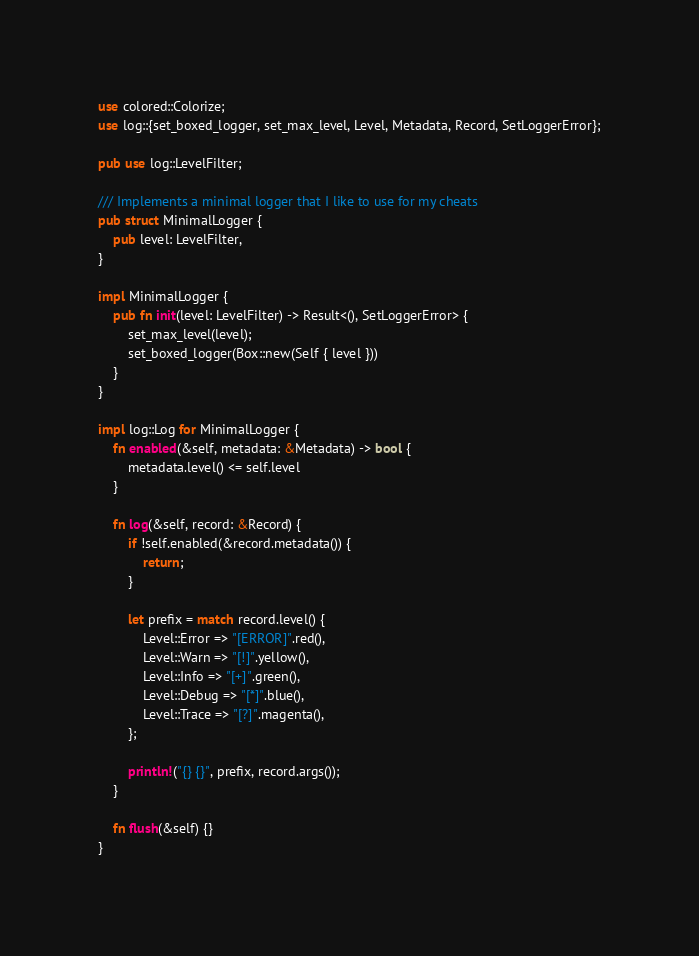Convert code to text. <code><loc_0><loc_0><loc_500><loc_500><_Rust_>use colored::Colorize;
use log::{set_boxed_logger, set_max_level, Level, Metadata, Record, SetLoggerError};

pub use log::LevelFilter;

/// Implements a minimal logger that I like to use for my cheats
pub struct MinimalLogger {
    pub level: LevelFilter,
}

impl MinimalLogger {
    pub fn init(level: LevelFilter) -> Result<(), SetLoggerError> {
        set_max_level(level);
        set_boxed_logger(Box::new(Self { level }))
    }
}

impl log::Log for MinimalLogger {
    fn enabled(&self, metadata: &Metadata) -> bool {
        metadata.level() <= self.level
    }

    fn log(&self, record: &Record) {
        if !self.enabled(&record.metadata()) {
            return;
        }

        let prefix = match record.level() {
            Level::Error => "[ERROR]".red(),
            Level::Warn => "[!]".yellow(),
            Level::Info => "[+]".green(),
            Level::Debug => "[*]".blue(),
            Level::Trace => "[?]".magenta(),
        };

        println!("{} {}", prefix, record.args());
    }

    fn flush(&self) {}
}
</code> 